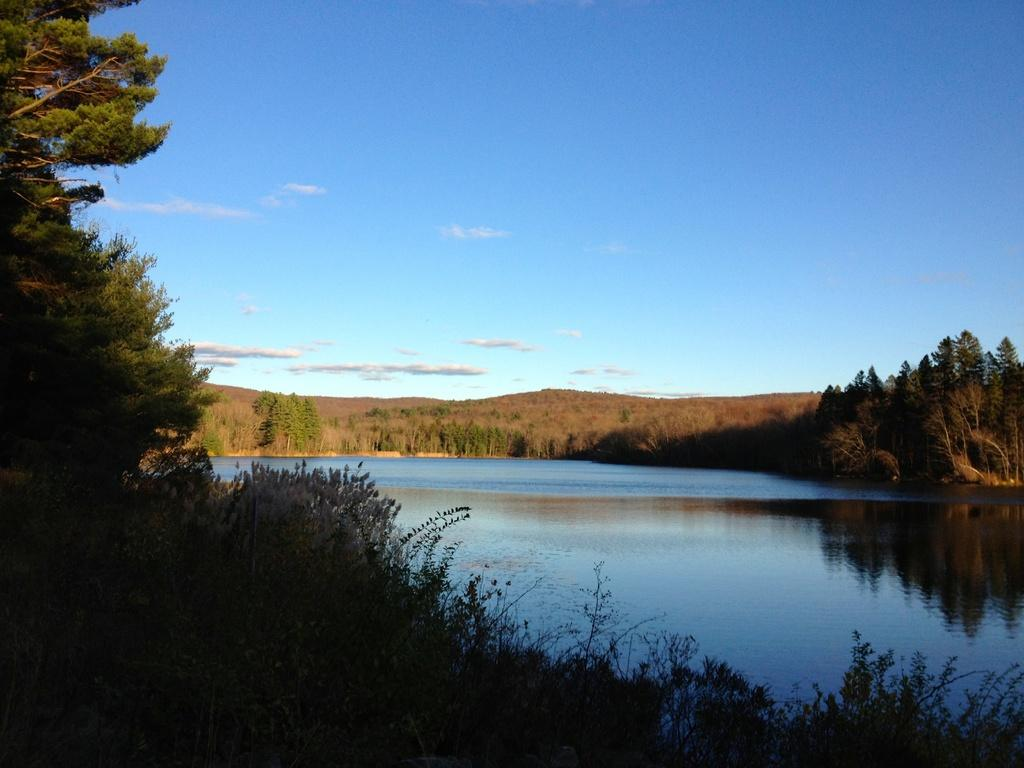What type of vegetation is present in the image? There is grass in the image. What else can be seen in the image besides grass? There is water visible in the image. What can be seen in the background of the image? There are trees and clouds in the sky in the background of the image. Who is the friend playing volleyball with in the image? There is no friend or volleyball present in the image. 